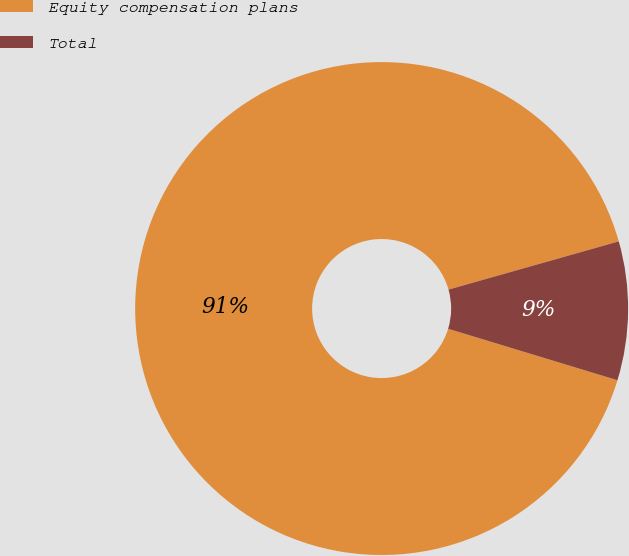Convert chart to OTSL. <chart><loc_0><loc_0><loc_500><loc_500><pie_chart><fcel>Equity compensation plans<fcel>Total<nl><fcel>90.91%<fcel>9.09%<nl></chart> 